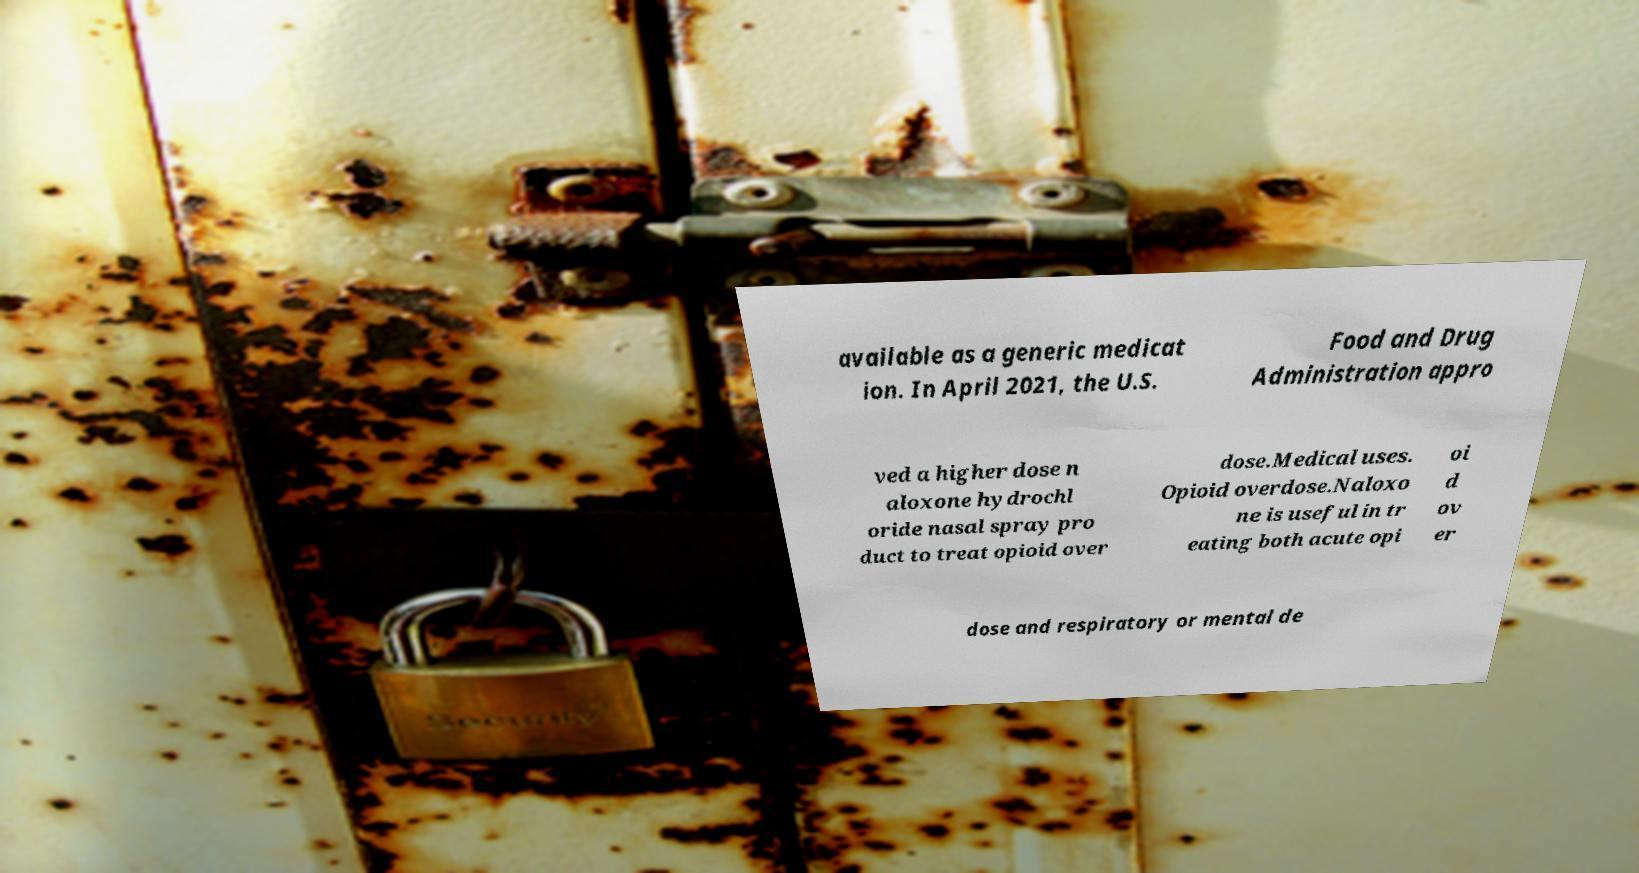Please identify and transcribe the text found in this image. available as a generic medicat ion. In April 2021, the U.S. Food and Drug Administration appro ved a higher dose n aloxone hydrochl oride nasal spray pro duct to treat opioid over dose.Medical uses. Opioid overdose.Naloxo ne is useful in tr eating both acute opi oi d ov er dose and respiratory or mental de 